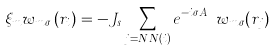Convert formula to latex. <formula><loc_0><loc_0><loc_500><loc_500>\xi _ { m } w _ { m \sigma } \left ( { r } _ { i } \right ) = - J _ { s } \sum _ { j = N N ( i ) } e ^ { - i \sigma A _ { j i } ^ { h } } w _ { m \sigma } ( { r } _ { j } )</formula> 